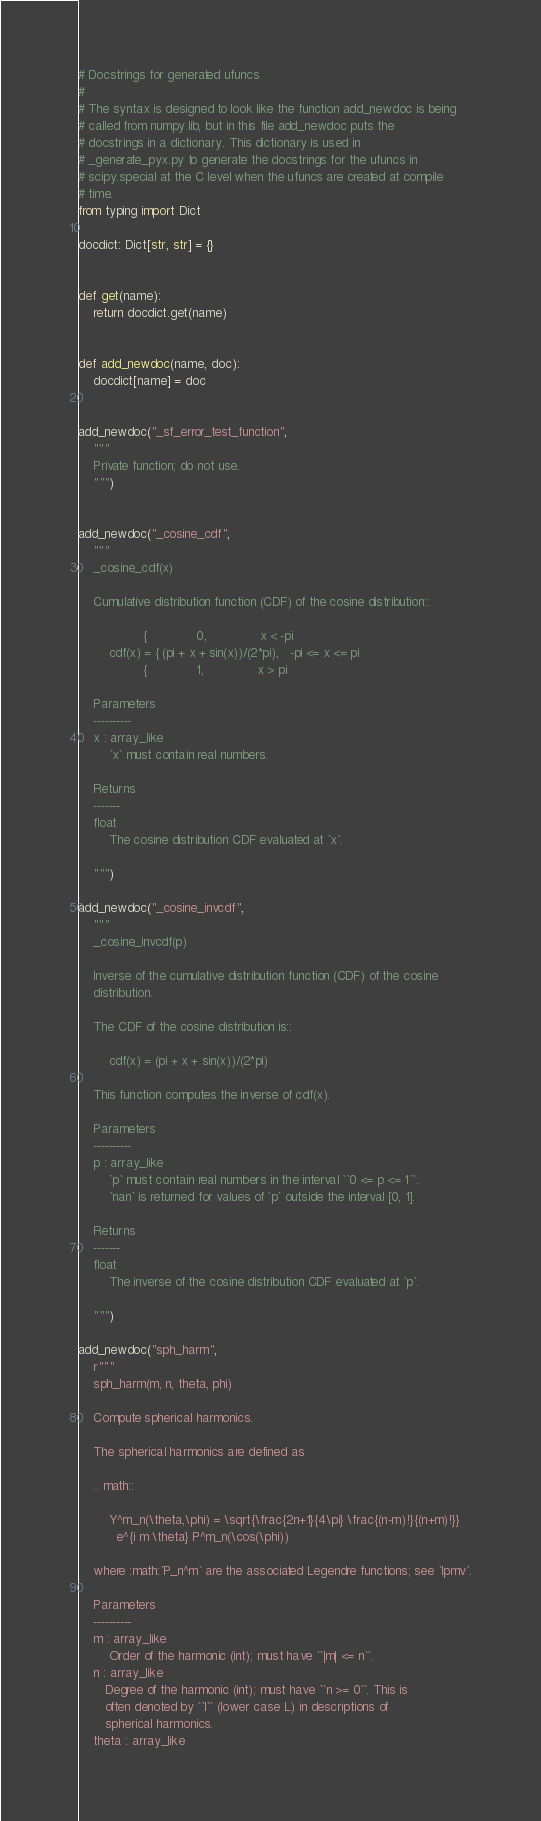Convert code to text. <code><loc_0><loc_0><loc_500><loc_500><_Python_># Docstrings for generated ufuncs
#
# The syntax is designed to look like the function add_newdoc is being
# called from numpy.lib, but in this file add_newdoc puts the
# docstrings in a dictionary. This dictionary is used in
# _generate_pyx.py to generate the docstrings for the ufuncs in
# scipy.special at the C level when the ufuncs are created at compile
# time.
from typing import Dict

docdict: Dict[str, str] = {}


def get(name):
    return docdict.get(name)


def add_newdoc(name, doc):
    docdict[name] = doc


add_newdoc("_sf_error_test_function",
    """
    Private function; do not use.
    """)


add_newdoc("_cosine_cdf",
    """
    _cosine_cdf(x)

    Cumulative distribution function (CDF) of the cosine distribution::

                 {             0,              x < -pi
        cdf(x) = { (pi + x + sin(x))/(2*pi),   -pi <= x <= pi
                 {             1,              x > pi

    Parameters
    ----------
    x : array_like
        `x` must contain real numbers.

    Returns
    -------
    float
        The cosine distribution CDF evaluated at `x`.

    """)

add_newdoc("_cosine_invcdf",
    """
    _cosine_invcdf(p)

    Inverse of the cumulative distribution function (CDF) of the cosine
    distribution.

    The CDF of the cosine distribution is::

        cdf(x) = (pi + x + sin(x))/(2*pi)

    This function computes the inverse of cdf(x).

    Parameters
    ----------
    p : array_like
        `p` must contain real numbers in the interval ``0 <= p <= 1``.
        `nan` is returned for values of `p` outside the interval [0, 1].

    Returns
    -------
    float
        The inverse of the cosine distribution CDF evaluated at `p`.

    """)

add_newdoc("sph_harm",
    r"""
    sph_harm(m, n, theta, phi)

    Compute spherical harmonics.

    The spherical harmonics are defined as

    .. math::

        Y^m_n(\theta,\phi) = \sqrt{\frac{2n+1}{4\pi} \frac{(n-m)!}{(n+m)!}}
          e^{i m \theta} P^m_n(\cos(\phi))

    where :math:`P_n^m` are the associated Legendre functions; see `lpmv`.

    Parameters
    ----------
    m : array_like
        Order of the harmonic (int); must have ``|m| <= n``.
    n : array_like
       Degree of the harmonic (int); must have ``n >= 0``. This is
       often denoted by ``l`` (lower case L) in descriptions of
       spherical harmonics.
    theta : array_like</code> 